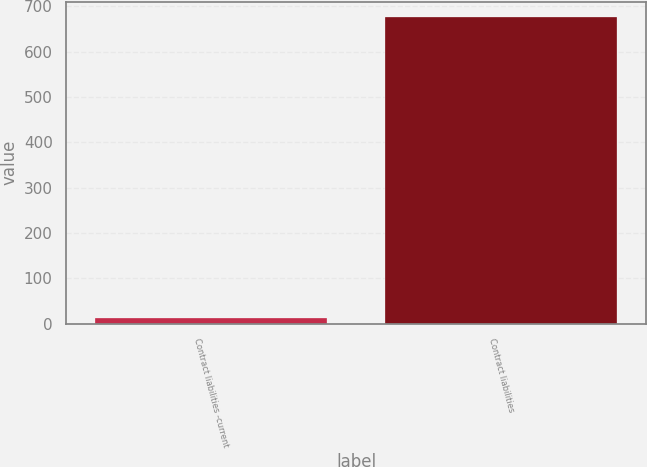Convert chart. <chart><loc_0><loc_0><loc_500><loc_500><bar_chart><fcel>Contract liabilities -current<fcel>Contract liabilities<nl><fcel>13.1<fcel>676.4<nl></chart> 